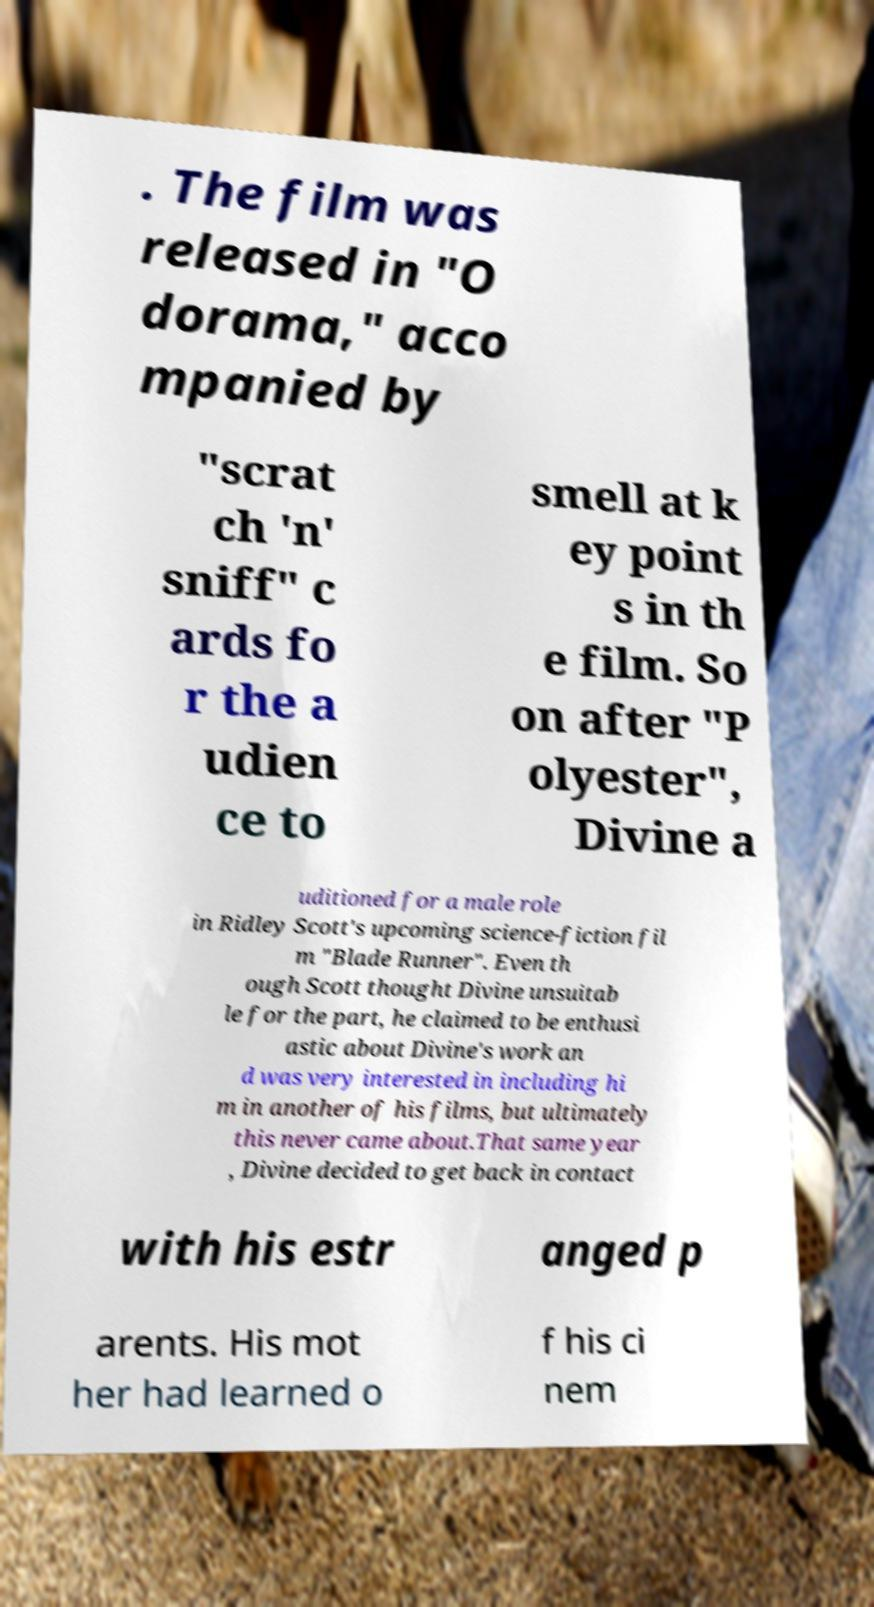For documentation purposes, I need the text within this image transcribed. Could you provide that? . The film was released in "O dorama," acco mpanied by "scrat ch 'n' sniff" c ards fo r the a udien ce to smell at k ey point s in th e film. So on after "P olyester", Divine a uditioned for a male role in Ridley Scott's upcoming science-fiction fil m "Blade Runner". Even th ough Scott thought Divine unsuitab le for the part, he claimed to be enthusi astic about Divine's work an d was very interested in including hi m in another of his films, but ultimately this never came about.That same year , Divine decided to get back in contact with his estr anged p arents. His mot her had learned o f his ci nem 